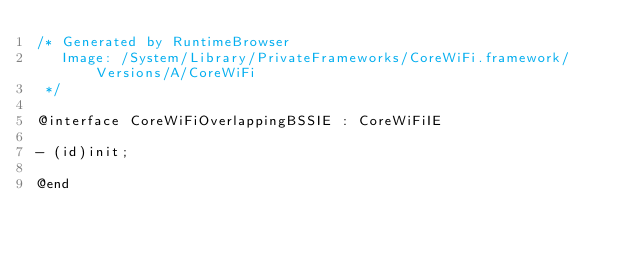<code> <loc_0><loc_0><loc_500><loc_500><_C_>/* Generated by RuntimeBrowser
   Image: /System/Library/PrivateFrameworks/CoreWiFi.framework/Versions/A/CoreWiFi
 */

@interface CoreWiFiOverlappingBSSIE : CoreWiFiIE

- (id)init;

@end
</code> 